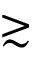<formula> <loc_0><loc_0><loc_500><loc_500>\gtrsim</formula> 